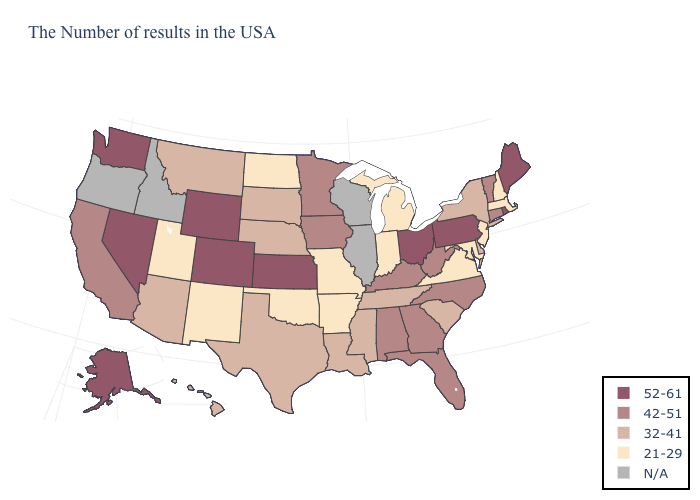Does the map have missing data?
Short answer required. Yes. What is the value of Maryland?
Concise answer only. 21-29. How many symbols are there in the legend?
Give a very brief answer. 5. What is the lowest value in states that border Tennessee?
Give a very brief answer. 21-29. Name the states that have a value in the range 21-29?
Quick response, please. Massachusetts, New Hampshire, New Jersey, Maryland, Virginia, Michigan, Indiana, Missouri, Arkansas, Oklahoma, North Dakota, New Mexico, Utah. What is the value of Arkansas?
Be succinct. 21-29. What is the highest value in the South ?
Short answer required. 42-51. Which states have the highest value in the USA?
Write a very short answer. Maine, Rhode Island, Pennsylvania, Ohio, Kansas, Wyoming, Colorado, Nevada, Washington, Alaska. Which states have the lowest value in the USA?
Concise answer only. Massachusetts, New Hampshire, New Jersey, Maryland, Virginia, Michigan, Indiana, Missouri, Arkansas, Oklahoma, North Dakota, New Mexico, Utah. Does Kansas have the lowest value in the MidWest?
Be succinct. No. Among the states that border Arkansas , does Missouri have the lowest value?
Give a very brief answer. Yes. Which states hav the highest value in the MidWest?
Keep it brief. Ohio, Kansas. What is the value of Texas?
Be succinct. 32-41. Does Florida have the lowest value in the USA?
Short answer required. No. 